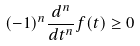Convert formula to latex. <formula><loc_0><loc_0><loc_500><loc_500>( - 1 ) ^ { n } \frac { d ^ { n } } { d t ^ { n } } f ( t ) \geq 0</formula> 